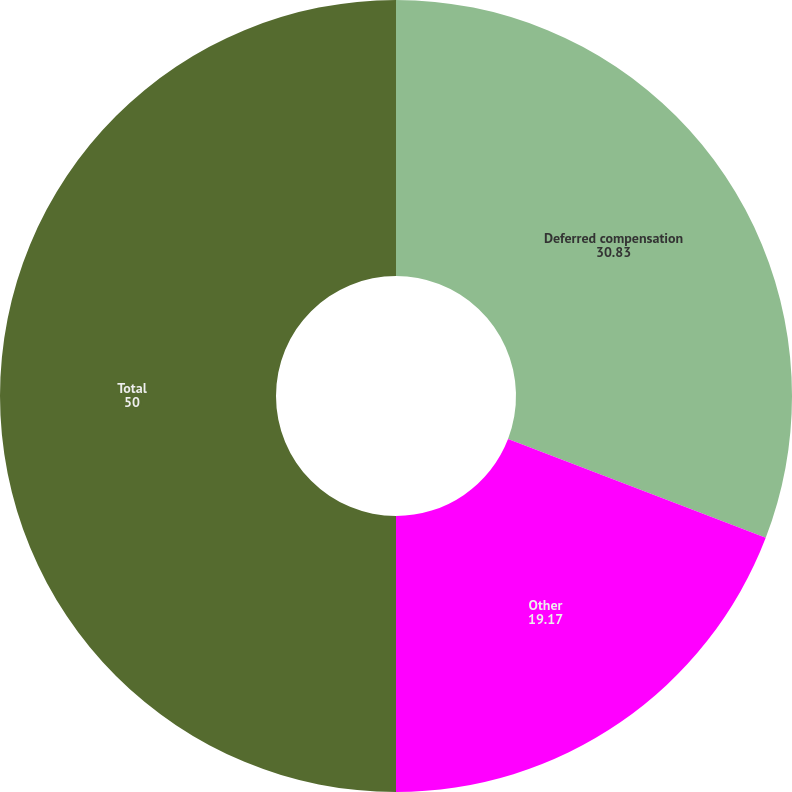<chart> <loc_0><loc_0><loc_500><loc_500><pie_chart><fcel>Deferred compensation<fcel>Other<fcel>Total<nl><fcel>30.83%<fcel>19.17%<fcel>50.0%<nl></chart> 